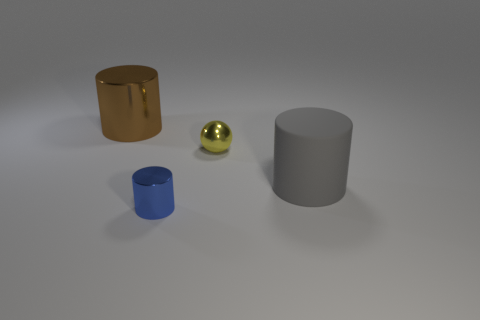Are there any other things that have the same material as the big gray thing?
Keep it short and to the point. No. Does the big cylinder in front of the large brown shiny cylinder have the same material as the yellow thing?
Ensure brevity in your answer.  No. How many blue things are either large matte cylinders or small metal objects?
Offer a terse response. 1. Are there any small yellow objects made of the same material as the blue object?
Your response must be concise. Yes. There is a metal object that is to the left of the yellow metal sphere and in front of the brown cylinder; what shape is it?
Your answer should be very brief. Cylinder. How many big objects are either brown shiny objects or rubber balls?
Your answer should be very brief. 1. What material is the blue cylinder?
Provide a short and direct response. Metal. How many other objects are there of the same shape as the matte thing?
Your answer should be very brief. 2. What size is the gray rubber object?
Provide a short and direct response. Large. How big is the cylinder that is both behind the blue cylinder and in front of the large metal cylinder?
Give a very brief answer. Large. 